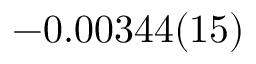Convert formula to latex. <formula><loc_0><loc_0><loc_500><loc_500>- 0 . 0 0 3 4 4 ( 1 5 )</formula> 